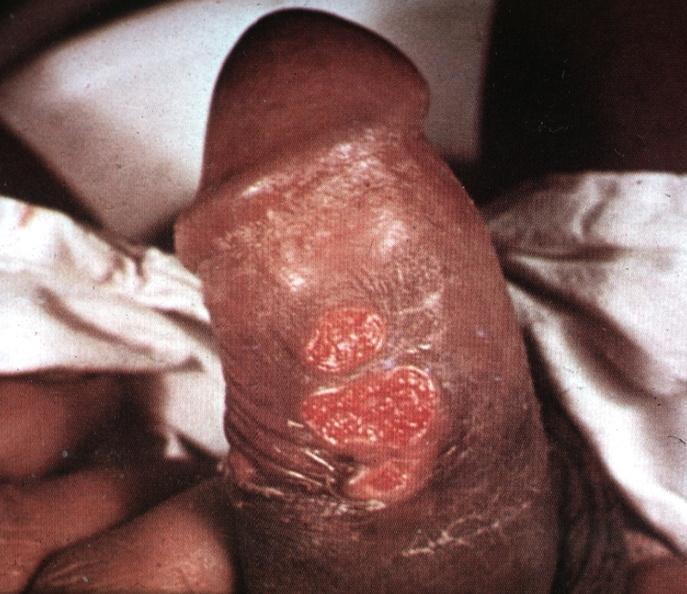s foot present?
Answer the question using a single word or phrase. No 